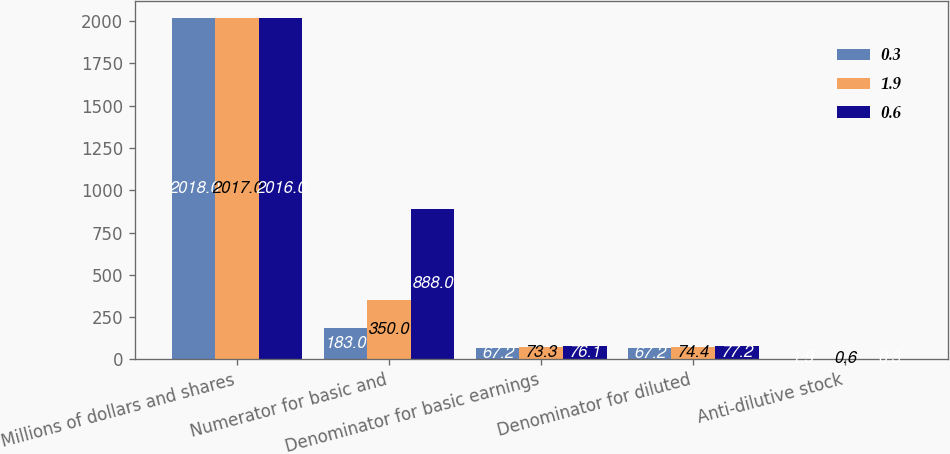Convert chart. <chart><loc_0><loc_0><loc_500><loc_500><stacked_bar_chart><ecel><fcel>Millions of dollars and shares<fcel>Numerator for basic and<fcel>Denominator for basic earnings<fcel>Denominator for diluted<fcel>Anti-dilutive stock<nl><fcel>0.3<fcel>2018<fcel>183<fcel>67.2<fcel>67.2<fcel>1.9<nl><fcel>1.9<fcel>2017<fcel>350<fcel>73.3<fcel>74.4<fcel>0.6<nl><fcel>0.6<fcel>2016<fcel>888<fcel>76.1<fcel>77.2<fcel>0.3<nl></chart> 